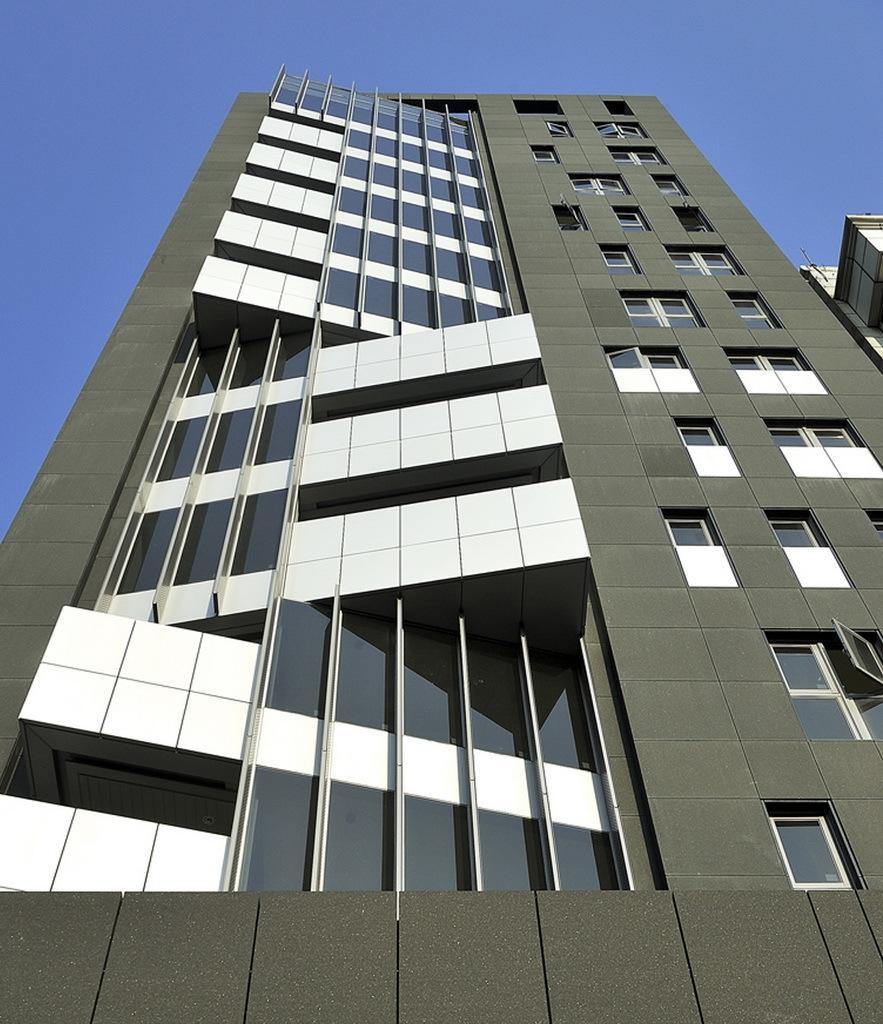How would you summarize this image in a sentence or two? In this picture I can observe a building. I can observe some windows in this building. In the background there is sky. 